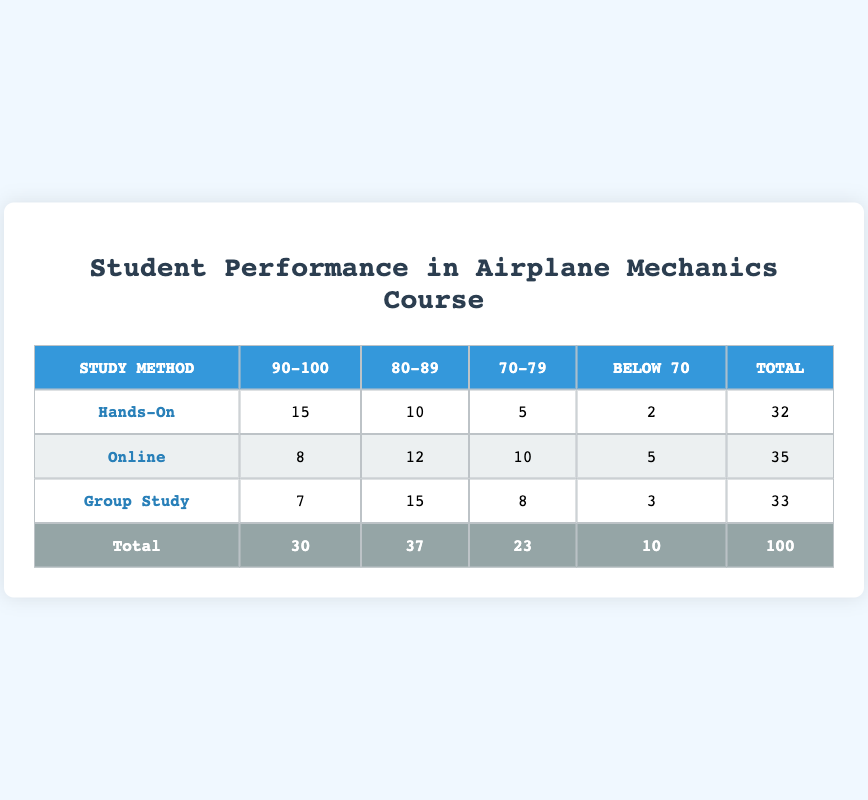What is the total number of students who scored 90-100? To find the total number of students who scored 90-100, we need to add the values in the 90-100 column for each study method: 15 (Hands-On) + 8 (Online) + 7 (Group Study) = 30.
Answer: 30 What is the total number of students who scored Below 70? The total number of students who scored Below 70 is obtained by adding the values in the Below 70 column: 2 (Hands-On) + 5 (Online) + 3 (Group Study) = 10.
Answer: 10 Which study method had the highest number of students scoring 80-89? By inspecting the 80-89 column, we find that the Group Study method has the highest value with 15 students compared to 10 (Hands-On) and 12 (Online).
Answer: Group Study Is it true that more students scored Below 70 for Online study than for Hands-On study? For Online, the value is 5, while for Hands-On, it is 2. Since 5 is greater than 2, the statement is true.
Answer: Yes What is the average number of students scoring 70-79 across all study methods? To calculate the average, we sum the values in the 70-79 column: 5 (Hands-On) + 10 (Online) + 8 (Group Study) = 23. We then divide by the number of study methods, which is 3: 23 / 3 ≈ 7.67.
Answer: 7.67 How many total students participated in the Hands-On study method? We can find the total students for the Hands-On method by adding all the numbers in its row: 15 (90-100) + 10 (80-89) + 5 (70-79) + 2 (Below 70) = 32.
Answer: 32 Which study method had the least number of students scoring 70-79? In the 70-79 column, the Hands-On method has 5 students, while Online has 10 and Group Study has 8, making it the least among the three.
Answer: Hands-On What is the difference in the number of students scoring 90-100 between Hands-On and Group Study? The number of students scoring 90-100 for Hands-On is 15, and for Group Study, it is 7: 15 - 7 = 8. The difference is 8 students.
Answer: 8 How many students scored 80-89 in total across all study methods? To find the total for the 80-89 scores, we sum the values: 10 (Hands-On) + 12 (Online) + 15 (Group Study) = 37.
Answer: 37 